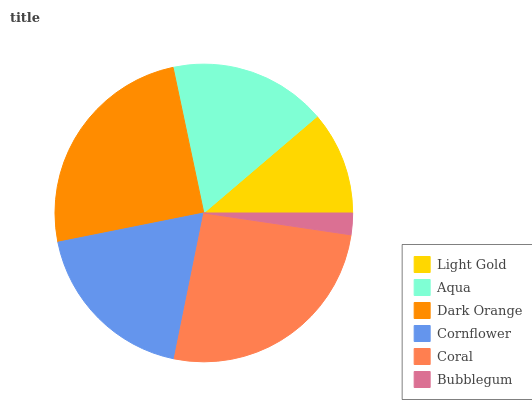Is Bubblegum the minimum?
Answer yes or no. Yes. Is Coral the maximum?
Answer yes or no. Yes. Is Aqua the minimum?
Answer yes or no. No. Is Aqua the maximum?
Answer yes or no. No. Is Aqua greater than Light Gold?
Answer yes or no. Yes. Is Light Gold less than Aqua?
Answer yes or no. Yes. Is Light Gold greater than Aqua?
Answer yes or no. No. Is Aqua less than Light Gold?
Answer yes or no. No. Is Cornflower the high median?
Answer yes or no. Yes. Is Aqua the low median?
Answer yes or no. Yes. Is Light Gold the high median?
Answer yes or no. No. Is Cornflower the low median?
Answer yes or no. No. 